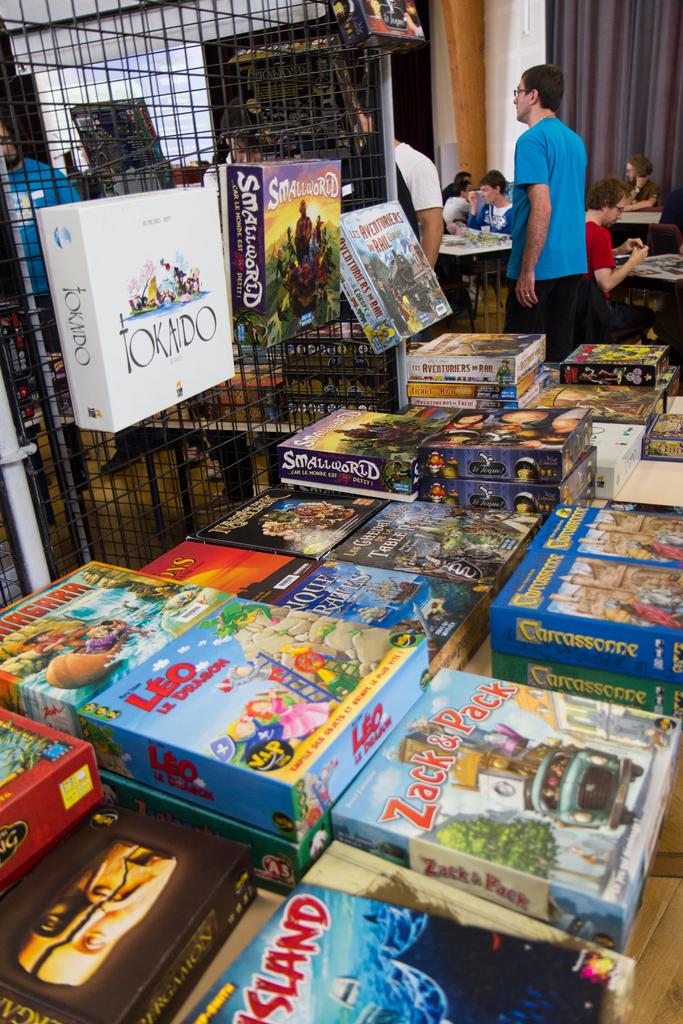The board game that says zach who is with him?
Your answer should be very brief. Pack. What is the name on the the white box?
Your answer should be compact. Tokaido. 